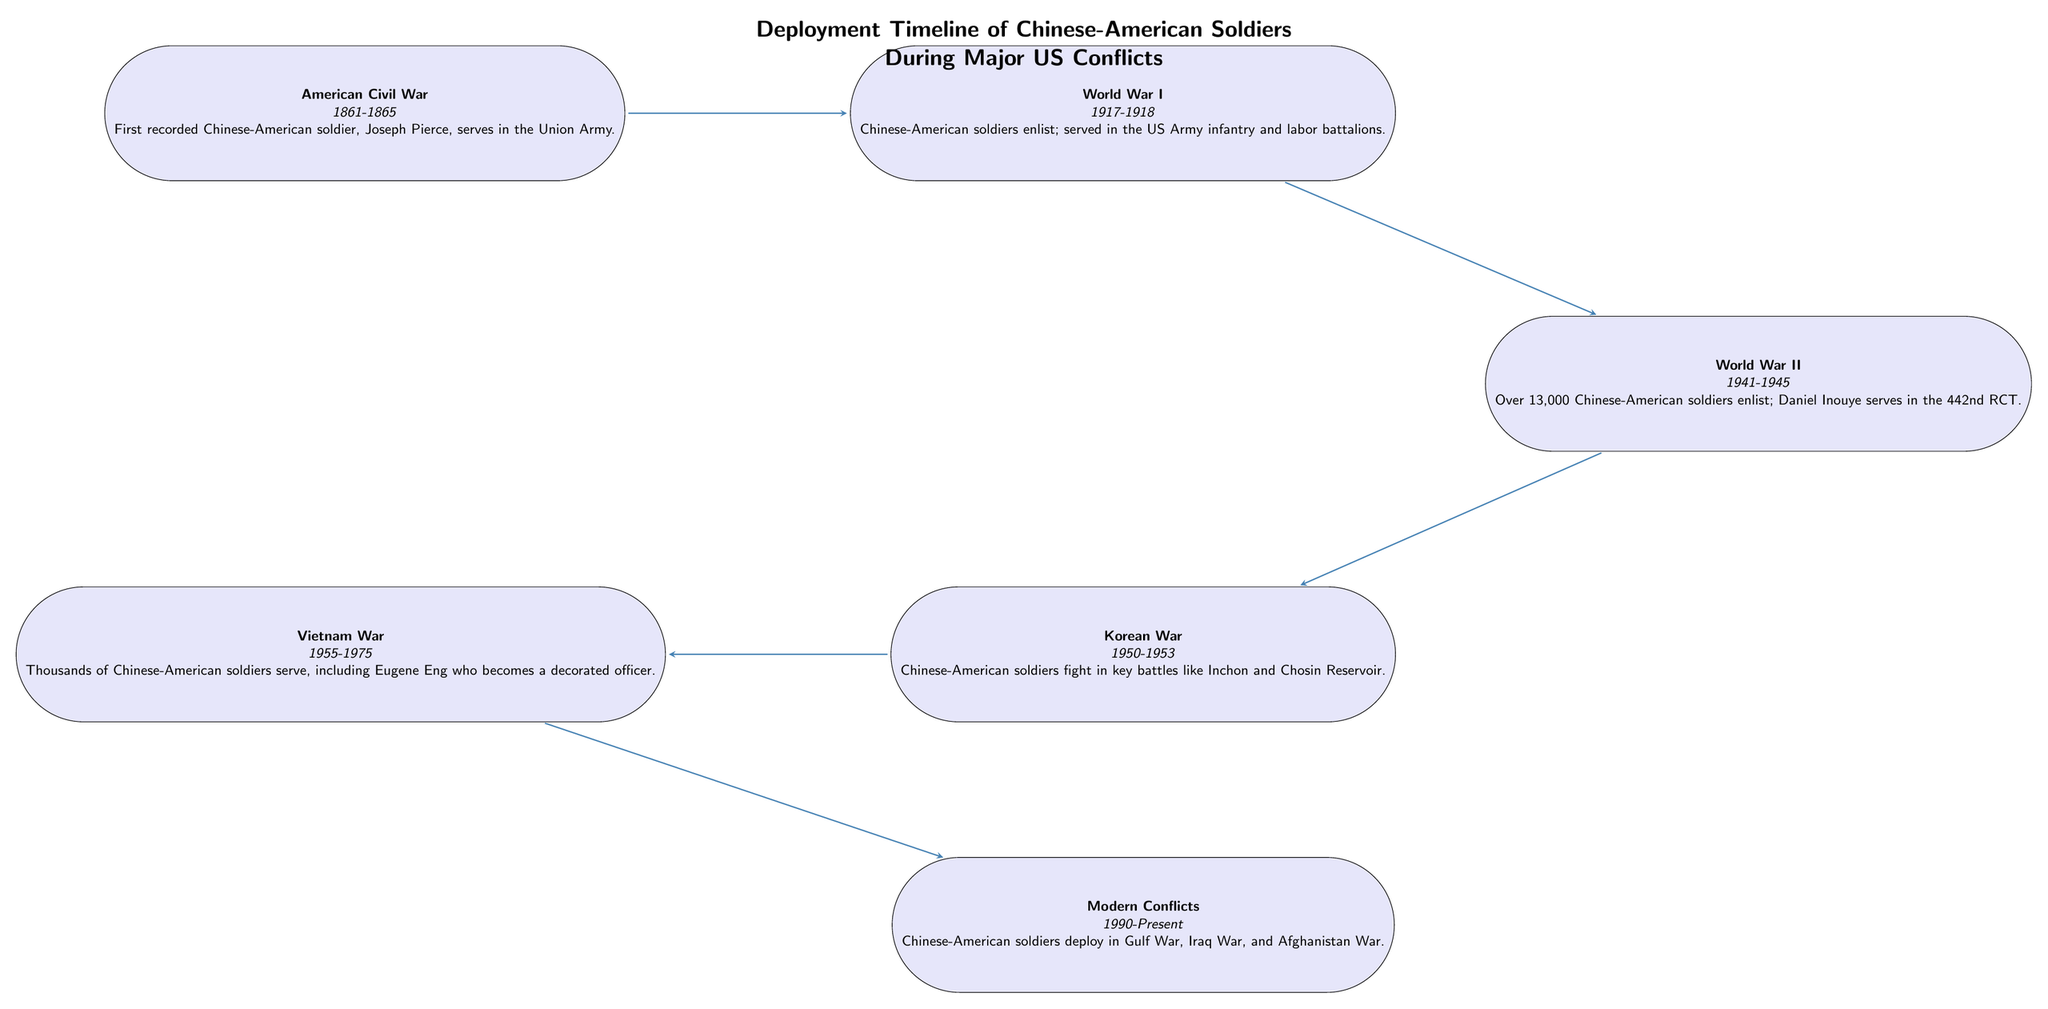What is the starting conflict shown in the timeline? The starting conflict is the American Civil War, which is explicitly mentioned as the first recorded event in the timeline.
Answer: American Civil War How many Chinese-American soldiers served in World War II? The diagram states that over 13,000 Chinese-American soldiers enlisted during World War II.
Answer: Over 13,000 Which notable figure served in the 442nd RCT during World War II? According to the diagram, Daniel Inouye is the notable figure who served in the 442nd RCT during World War II.
Answer: Daniel Inouye Which conflict immediately follows World War I in the timeline? The arrow indicates that World War II follows World War I directly in the chronological flowchart.
Answer: World War II In which conflict did Chinese-American soldiers participate in key battles like Inchon and Chosin Reservoir? The timeline specifies the Korean War as the conflict where Chinese-American soldiers fought in those significant battles.
Answer: Korean War Identify the two conflicts that involved Chinese-American soldiers prior to modern conflicts. To arrive at the answer, we need to look back two nodes before the modern conflicts node; these are the Vietnam War and the Korean War.
Answer: Vietnam War, Korean War What is the time span of the Vietnam War as depicted in the diagram? The diagram specifies the time span of the Vietnam War as 1955 to 1975, which is clearly stated in the Vietnam War node.
Answer: 1955-1975 How many major US conflicts are depicted in this timeline? Counting all the labeled conflicts in the diagram yields a total of six distinct events, from the Civil War to modern conflicts.
Answer: Six Which event shows the contribution of Joseph Pierce? The American Civil War node identifies Joseph Pierce as the first recorded Chinese-American soldier who served during this event.
Answer: American Civil War 